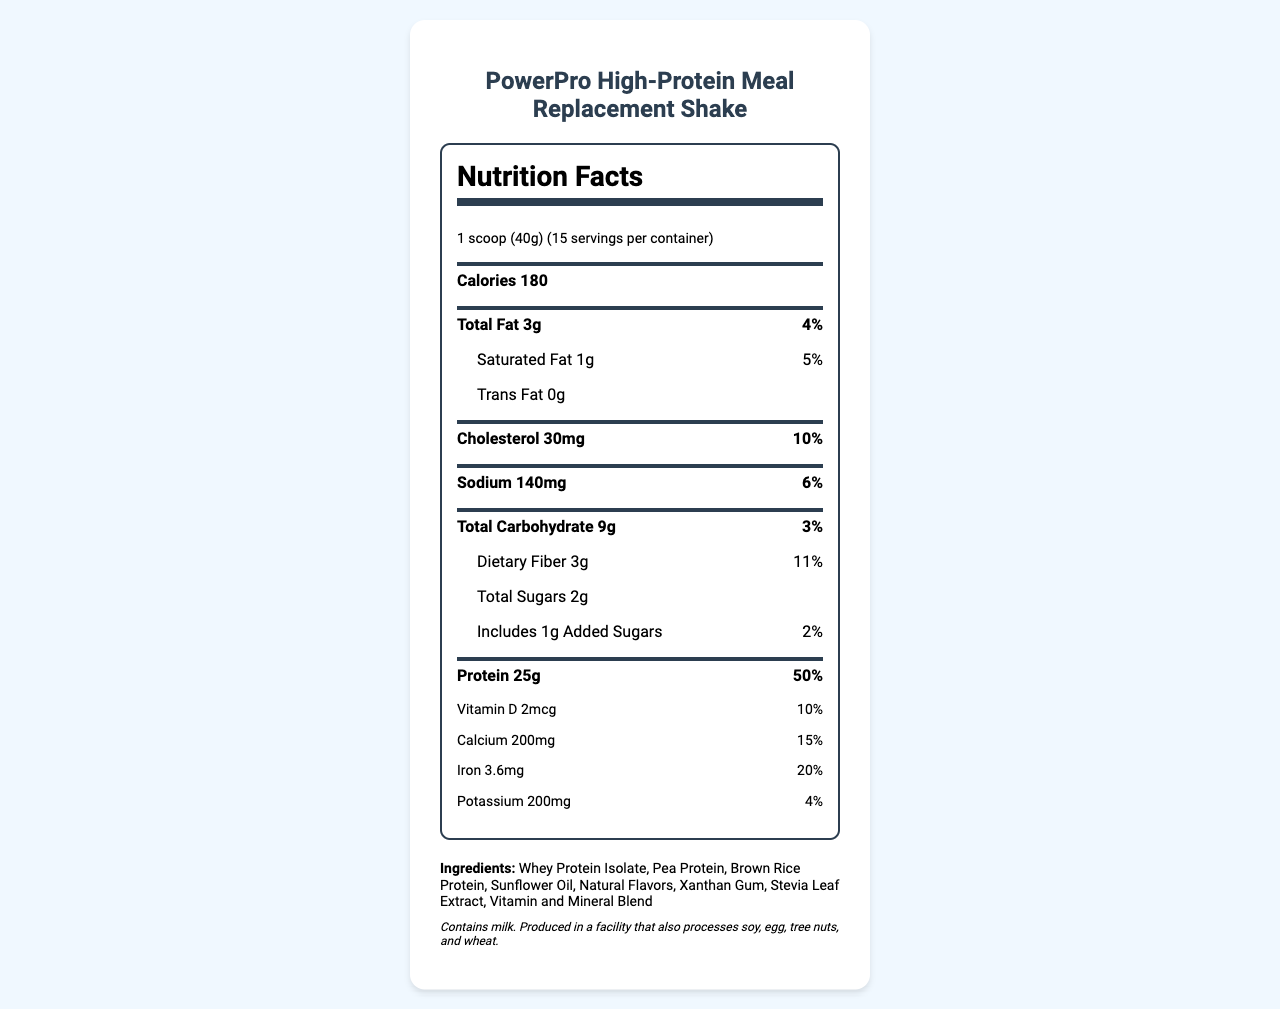what is the serving size? The serving size is clearly indicated as "1 scoop (40g)" in the Serving Info section of the Nutrition Facts.
Answer: 1 scoop (40g) how many calories per serving? The number of calories per serving is listed under the Calories section of the Nutrition Facts.
Answer: 180 how much protein is in one serving? The amount of protein per serving is listed under the main nutrients section as 25g.
Answer: 25g what is the daily value percentage for sodium? The daily value percentage for sodium is noted as 6% in the Sodium section.
Answer: 6% which ingredient is listed first? The first ingredient listed under the Ingredients section is Whey Protein Isolate.
Answer: Whey Protein Isolate which allergen is present in the product? A. Soy B. Milk C. Egg D. Wheat The allergen information section indicates that the product contains milk.
Answer: B what is the total fat content per serving? The total fat content per serving is listed as 3g in the main nutrients section.
Answer: 3g What percentage of the daily value does the saturated fat represent? The daily value percentage for saturated fat is listed as 5%.
Answer: 5% which vitamin has a 20% daily value in one serving? A. Vitamin D B. Calcium C. Iron D. Vitamin A The Iron section states that it has a 20% daily value per serving.
Answer: C How many servings are there in a container? The number of servings per container is indicated as 15 in the serving info section.
Answer: 15 is this product Non-GMO Project Verified? The Certifications section lists "Non-GMO Project Verified" as one of its certifications.
Answer: Yes Summarize the main points of the document. The summary covers the nutritional breakdown, serving details, ingredients, allergen information, certifications, and customer support info.
Answer: The document provides the Nutrition Facts for the PowerPro High-Protein Meal Replacement Shake. It details serving size (1 scoop, 40g), servings per container (15), and various nutritional contents such as calories (180), fats, cholesterol, sodium, carbohydrates, and protein (25g). It includes vitamin and mineral information, ingredients, allergen info, mixing instructions, flavor options, certifications, sustainability info, and customer support contact information. are there any trans fats in the product? The Trans Fat section confirms that there are 0g of trans fats per serving.
Answer: No what flavors are available? The Flavor Options section lists the available flavors of the shake.
Answer: Vanilla Bean, Rich Chocolate, Strawberry Cream, Cookies & Cream which vitamin/mineral has the highest daily value percentage in one serving? Protein is listed with a daily value of 50%, which is the highest among the nutrients listed.
Answer: Protein at 50% how much iron is there in each serving? The Iron section indicates that each serving contains 3.6mg of iron.
Answer: 3.6mg how much dietary fiber is in a serving of the shake? The amount of dietary fiber is listed as 3g in the main nutrients section.
Answer: 3g how many calories are from fat? The document does not specify the number of calories from fat, so this cannot be determined from the given information.
Answer: Not enough information 